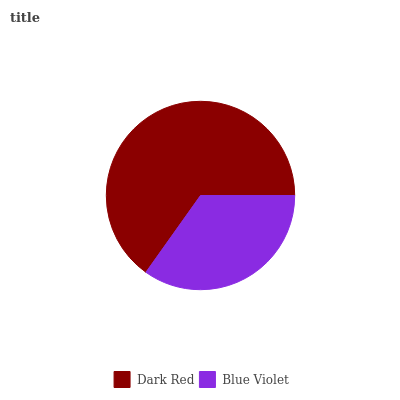Is Blue Violet the minimum?
Answer yes or no. Yes. Is Dark Red the maximum?
Answer yes or no. Yes. Is Blue Violet the maximum?
Answer yes or no. No. Is Dark Red greater than Blue Violet?
Answer yes or no. Yes. Is Blue Violet less than Dark Red?
Answer yes or no. Yes. Is Blue Violet greater than Dark Red?
Answer yes or no. No. Is Dark Red less than Blue Violet?
Answer yes or no. No. Is Dark Red the high median?
Answer yes or no. Yes. Is Blue Violet the low median?
Answer yes or no. Yes. Is Blue Violet the high median?
Answer yes or no. No. Is Dark Red the low median?
Answer yes or no. No. 